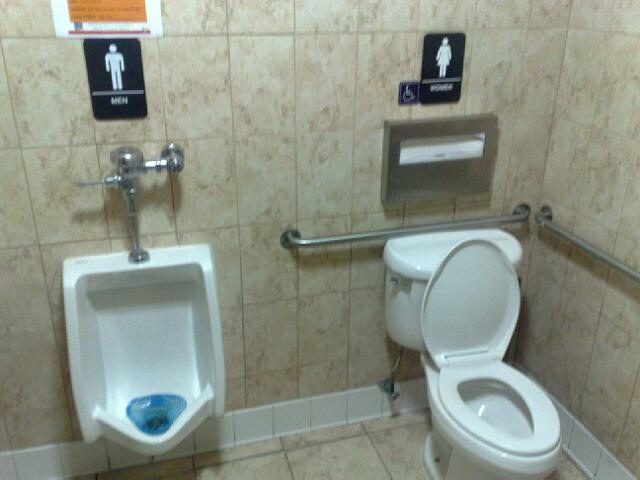Describe the objects in this image and their specific colors. I can see toilet in lightgray, darkgray, gray, and lightblue tones and toilet in lightgray, darkgray, lightblue, and gray tones in this image. 